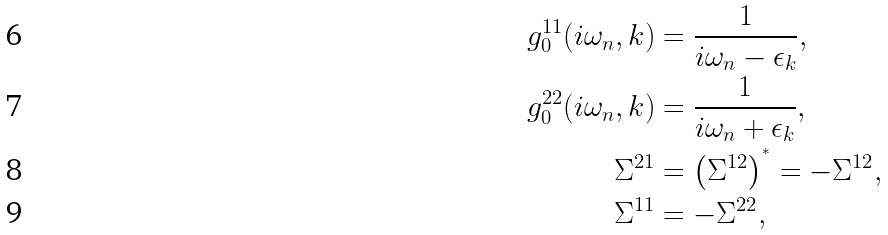<formula> <loc_0><loc_0><loc_500><loc_500>g _ { 0 } ^ { 1 1 } ( i \omega _ { n } , k ) & = \frac { 1 } { i \omega _ { n } - \epsilon _ { k } } , \\ g _ { 0 } ^ { 2 2 } ( i \omega _ { n } , k ) & = \frac { 1 } { i \omega _ { n } + \epsilon _ { k } } , \\ \Sigma ^ { 2 1 } & = \left ( \Sigma ^ { 1 2 } \right ) ^ { ^ { * } } = - \Sigma ^ { 1 2 } , \\ \Sigma ^ { 1 1 } & = - \Sigma ^ { 2 2 } ,</formula> 